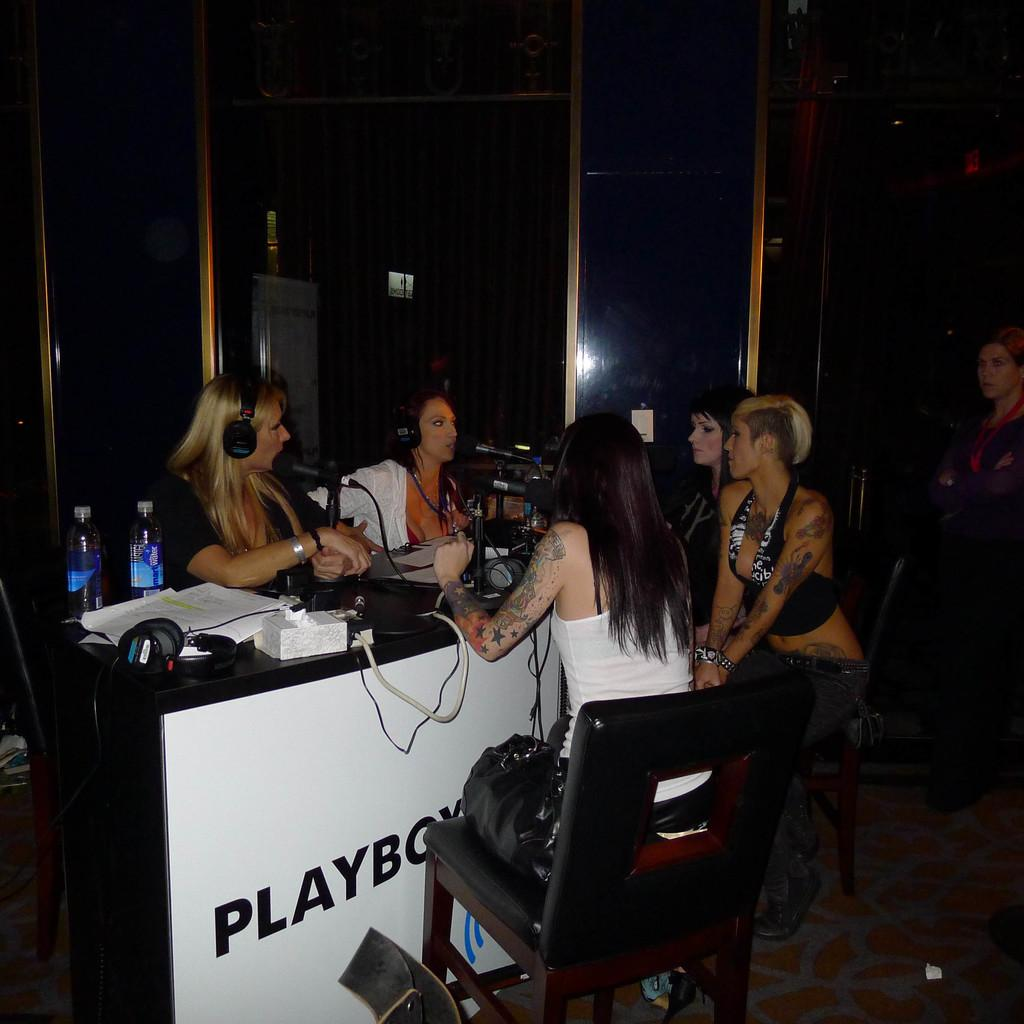What are the women in the image doing? The women in the image are sitting on chairs. What objects can be seen on the table in the image? There are mics on a table in the image. Can you describe the background of the image? There is a woman visible in the background of the image. What month is it in the image? The month cannot be determined from the image, as there is no information about the time of year or date. 